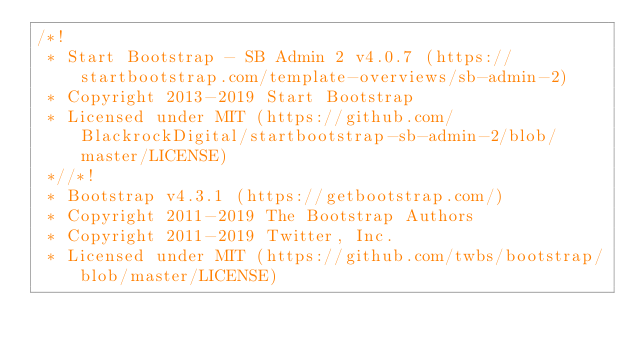Convert code to text. <code><loc_0><loc_0><loc_500><loc_500><_CSS_>/*!
 * Start Bootstrap - SB Admin 2 v4.0.7 (https://startbootstrap.com/template-overviews/sb-admin-2)
 * Copyright 2013-2019 Start Bootstrap
 * Licensed under MIT (https://github.com/BlackrockDigital/startbootstrap-sb-admin-2/blob/master/LICENSE)
 *//*!
 * Bootstrap v4.3.1 (https://getbootstrap.com/)
 * Copyright 2011-2019 The Bootstrap Authors
 * Copyright 2011-2019 Twitter, Inc.
 * Licensed under MIT (https://github.com/twbs/bootstrap/blob/master/LICENSE)</code> 